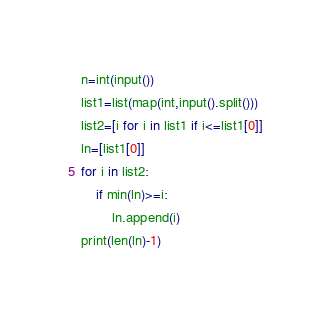<code> <loc_0><loc_0><loc_500><loc_500><_Python_>n=int(input())
list1=list(map(int,input().split()))
list2=[i for i in list1 if i<=list1[0]]
ln=[list1[0]]
for i in list2:
    if min(ln)>=i:
        ln.append(i)
print(len(ln)-1)</code> 